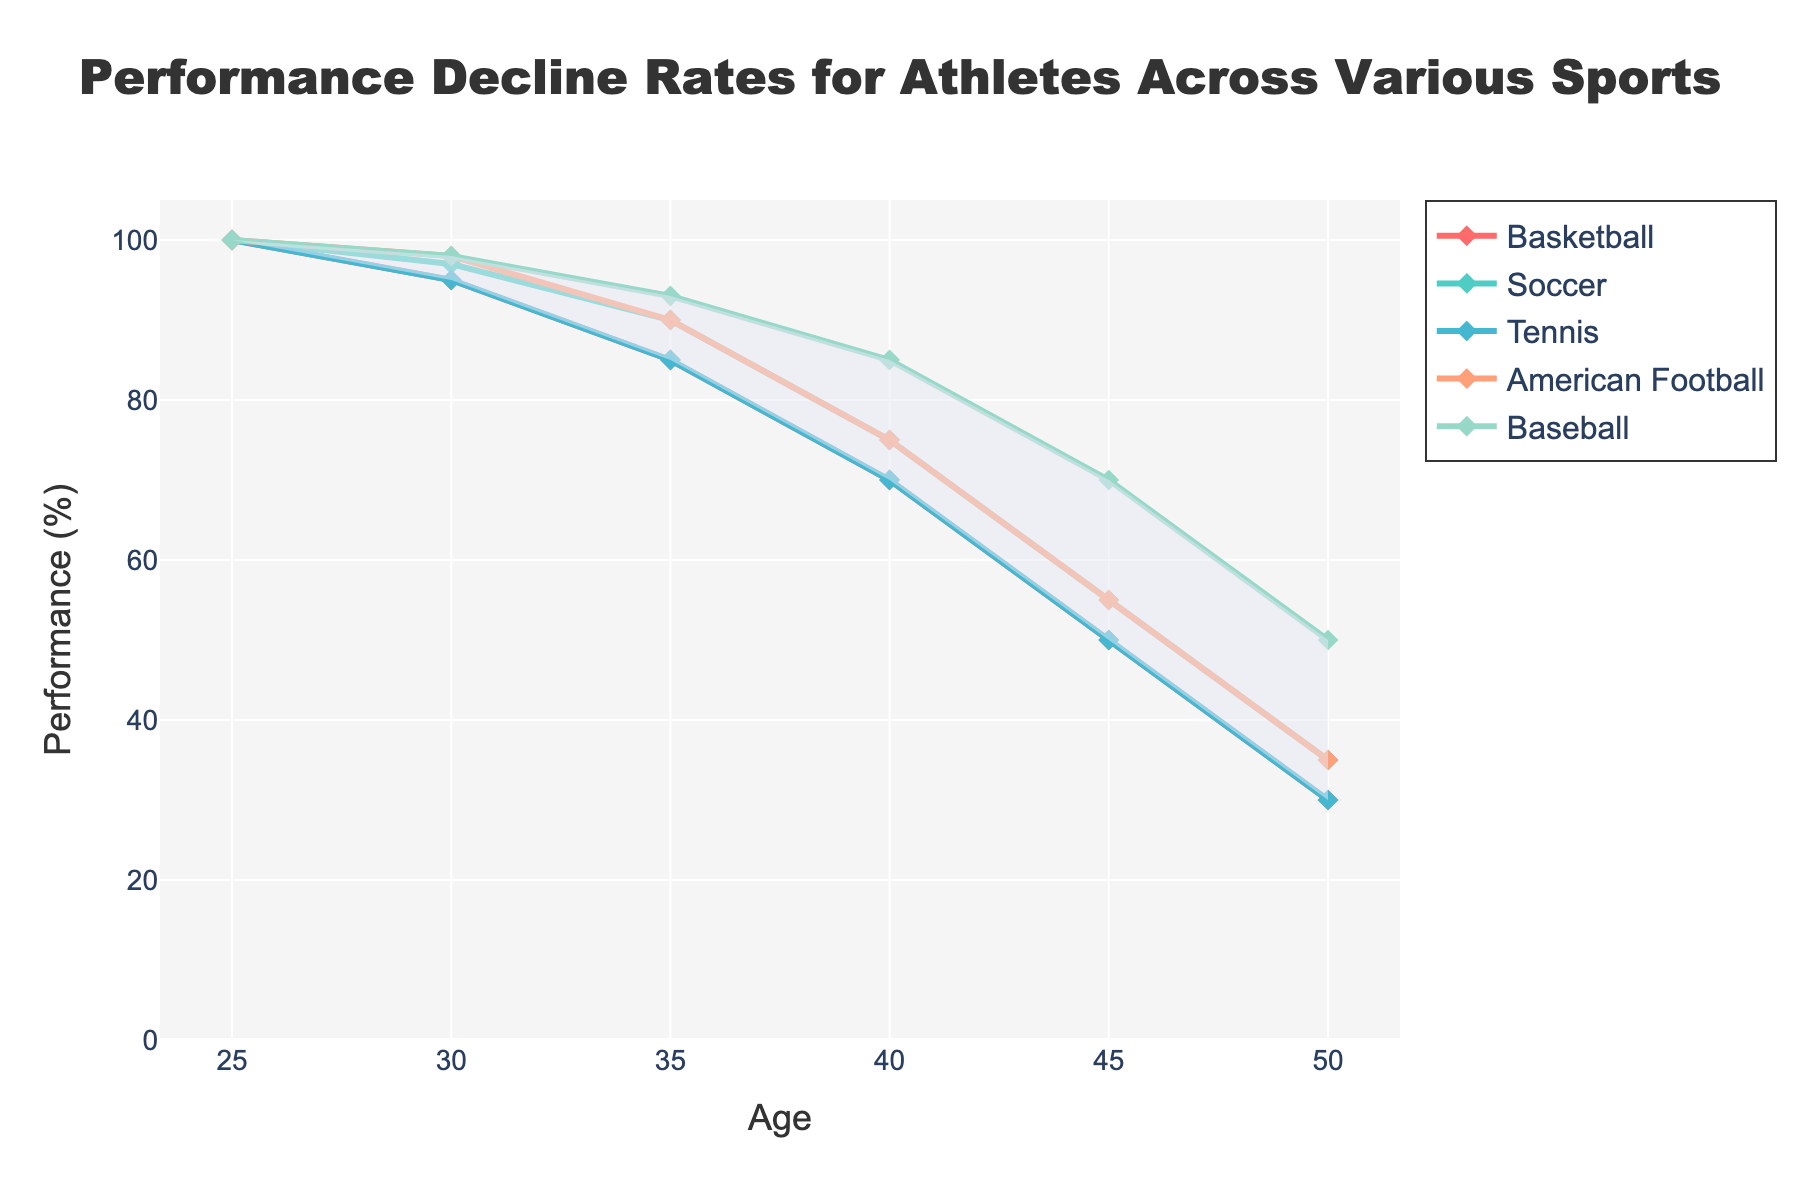What is the title of the chart? The title of the chart is usually found at the top and it summarizes the content of the chart. In this case, the title clearly indicates the subject matter.
Answer: Performance Decline Rates for Athletes Across Various Sports What is the age range shown on the x-axis? The age range can be determined by looking at the values along the x-axis, which represent the different ages in the chart. The chart starts at 25 and ends at 50.
Answer: 25 to 50 Which sport shows the least decline in performance from age 25 to 30? Look at the lines for each sport and see which one has the smallest drop from the point at age 25 to the point at age 30. Soccer shows a slight decline from 100 to 97, which is the smallest decline among all the sports.
Answer: Soccer At what age does Tennis performance drop to 50%? Identify the line corresponding to Tennis and find the age at which the performance value equals 50%. For Tennis, the performance reaches 50% at age 45.
Answer: 45 What is the performance percentage for American Football at age 40? Locate the point on the American Football line at age 40 and read the performance value. The performance percentage for American Football at this age is 75.
Answer: 75 Which sport retains the highest performance at age 50? At age 50, find the performance values for all the sports and identify the highest one. Baseball retains the highest performance at 50%.
Answer: Baseball How does the average performance at age 35 compare across all the sports? Calculate the average performance values at age 35 for Basketball, Soccer, Tennis, American Football, and Baseball. The values are 85, 90, 85, 90, and 93, respectively. The sum is 443, and the average is 443/5.
Answer: 88.6 Between age 30 and age 45, which sport shows the highest rate of decline? Compute the rate of performance decline for each sport between age 30 and age 45. For Basketball, it's 95 to 50, Soccer is 97 to 55, Tennis is 95 to 50, American Football is 98 to 55, and Baseball is 98 to 70. Calculate the decline and identify the highest. Soccer's decline is the largest.
Answer: Soccer Is there any age where all sports have the same performance rate? Examine each age along the x-axis and compare the performance rates for all sports. There is no age where the performance rates for all sports are identical.
Answer: No What is the shaded area in the chart indicating? The shaded area in a fan chart typically represents the range between the highest and lowest performances across the sports, giving a visual indication of the spread of performance values at each age.
Answer: Range of performances 